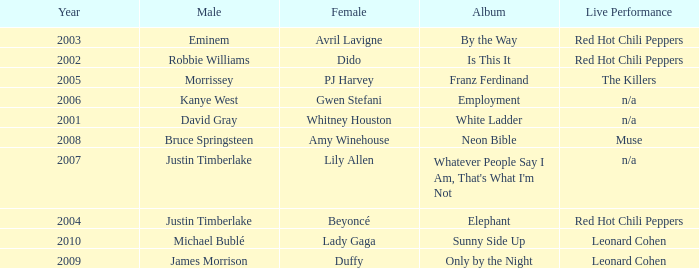Which female artist has an album named elephant? Beyoncé. 